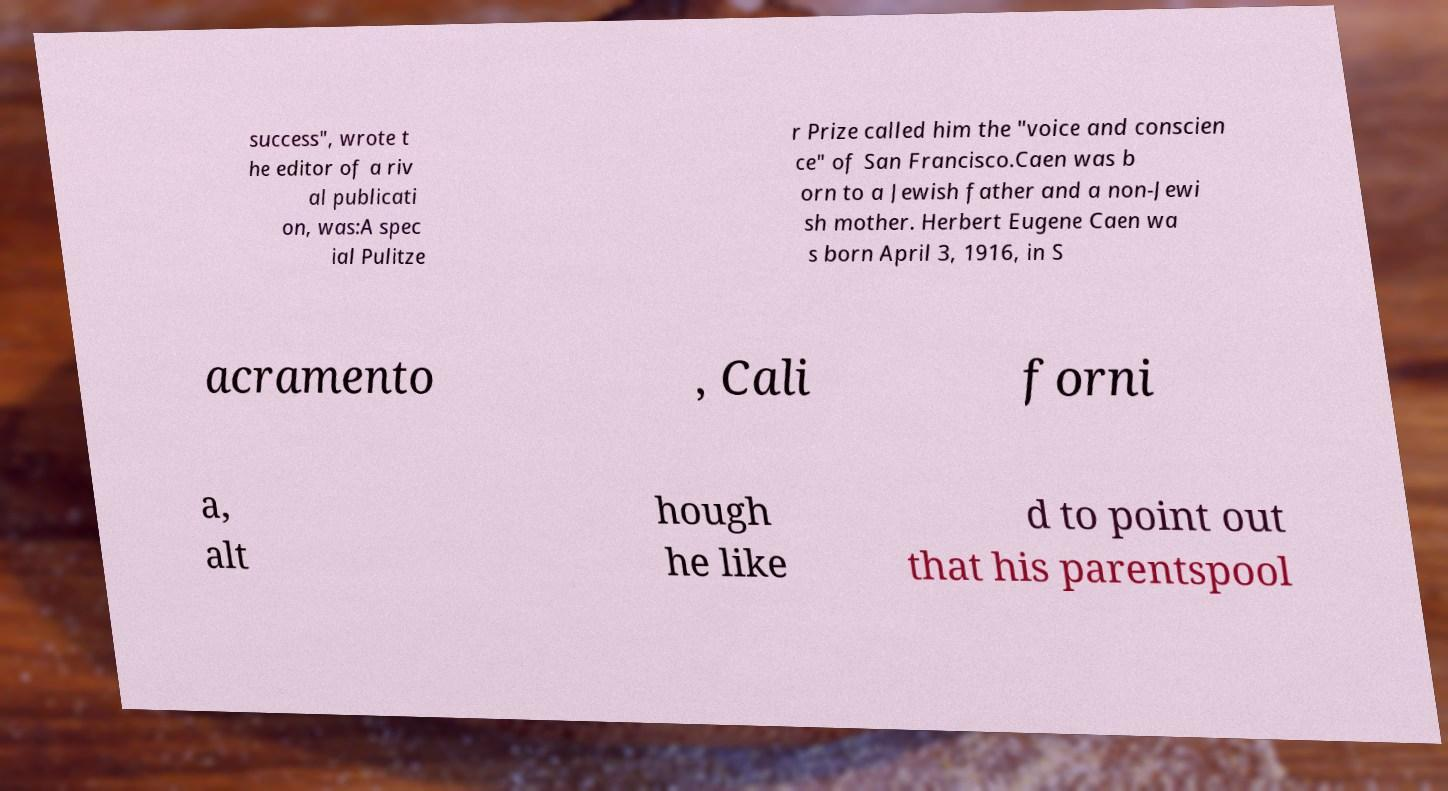There's text embedded in this image that I need extracted. Can you transcribe it verbatim? success", wrote t he editor of a riv al publicati on, was:A spec ial Pulitze r Prize called him the "voice and conscien ce" of San Francisco.Caen was b orn to a Jewish father and a non-Jewi sh mother. Herbert Eugene Caen wa s born April 3, 1916, in S acramento , Cali forni a, alt hough he like d to point out that his parentspool 